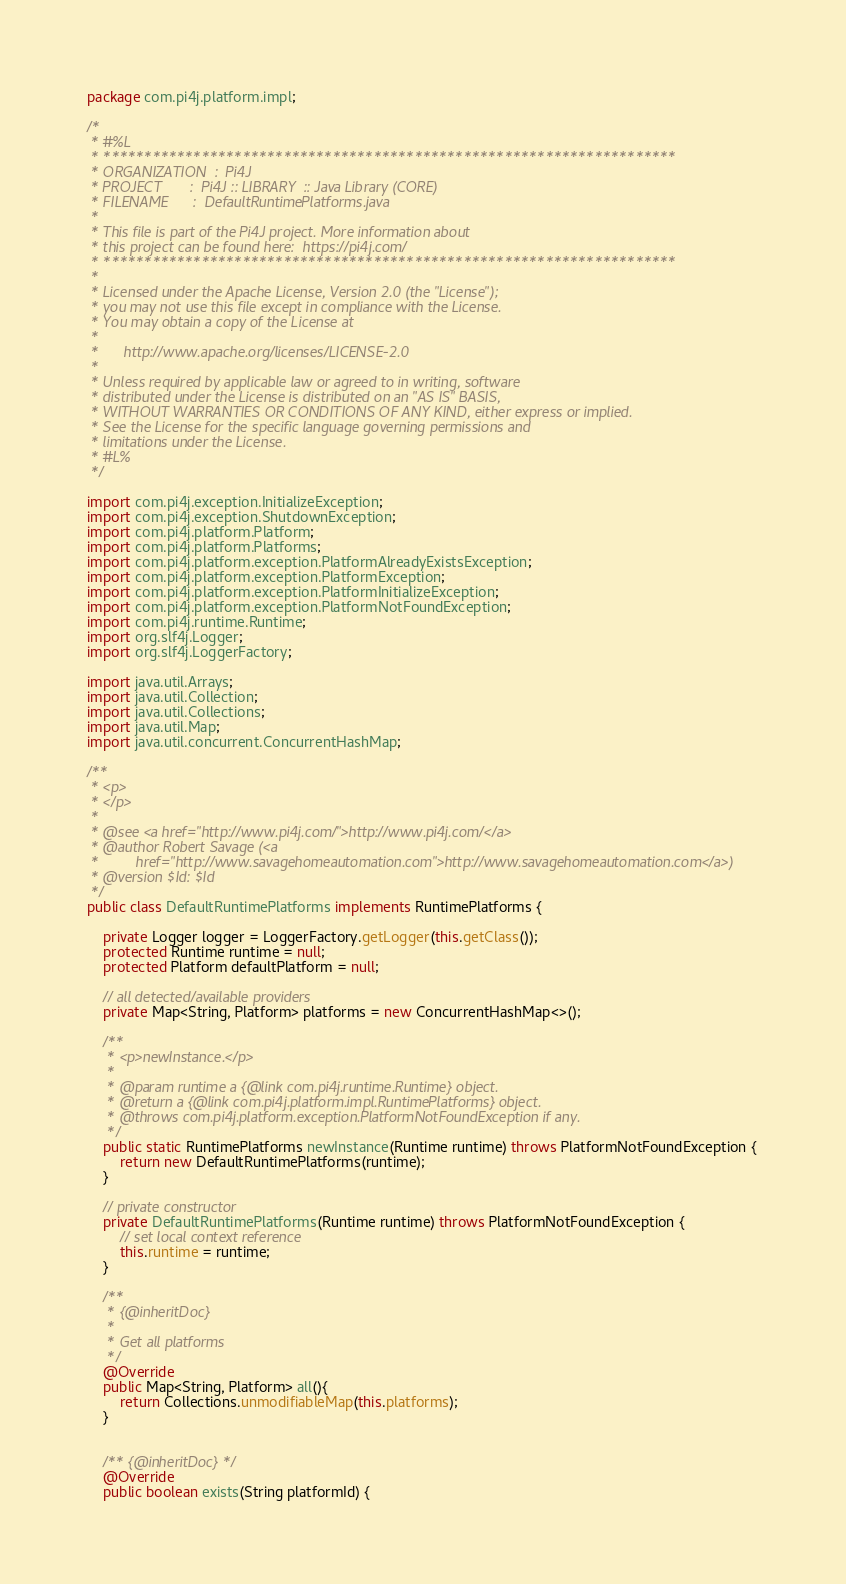<code> <loc_0><loc_0><loc_500><loc_500><_Java_>package com.pi4j.platform.impl;

/*
 * #%L
 * **********************************************************************
 * ORGANIZATION  :  Pi4J
 * PROJECT       :  Pi4J :: LIBRARY  :: Java Library (CORE)
 * FILENAME      :  DefaultRuntimePlatforms.java
 *
 * This file is part of the Pi4J project. More information about
 * this project can be found here:  https://pi4j.com/
 * **********************************************************************
 *
 * Licensed under the Apache License, Version 2.0 (the "License");
 * you may not use this file except in compliance with the License.
 * You may obtain a copy of the License at
 *
 *      http://www.apache.org/licenses/LICENSE-2.0
 *
 * Unless required by applicable law or agreed to in writing, software
 * distributed under the License is distributed on an "AS IS" BASIS,
 * WITHOUT WARRANTIES OR CONDITIONS OF ANY KIND, either express or implied.
 * See the License for the specific language governing permissions and
 * limitations under the License.
 * #L%
 */

import com.pi4j.exception.InitializeException;
import com.pi4j.exception.ShutdownException;
import com.pi4j.platform.Platform;
import com.pi4j.platform.Platforms;
import com.pi4j.platform.exception.PlatformAlreadyExistsException;
import com.pi4j.platform.exception.PlatformException;
import com.pi4j.platform.exception.PlatformInitializeException;
import com.pi4j.platform.exception.PlatformNotFoundException;
import com.pi4j.runtime.Runtime;
import org.slf4j.Logger;
import org.slf4j.LoggerFactory;

import java.util.Arrays;
import java.util.Collection;
import java.util.Collections;
import java.util.Map;
import java.util.concurrent.ConcurrentHashMap;

/**
 * <p>
 * </p>
 *
 * @see <a href="http://www.pi4j.com/">http://www.pi4j.com/</a>
 * @author Robert Savage (<a
 *         href="http://www.savagehomeautomation.com">http://www.savagehomeautomation.com</a>)
 * @version $Id: $Id
 */
public class DefaultRuntimePlatforms implements RuntimePlatforms {

    private Logger logger = LoggerFactory.getLogger(this.getClass());
    protected Runtime runtime = null;
    protected Platform defaultPlatform = null;

    // all detected/available providers
    private Map<String, Platform> platforms = new ConcurrentHashMap<>();

    /**
     * <p>newInstance.</p>
     *
     * @param runtime a {@link com.pi4j.runtime.Runtime} object.
     * @return a {@link com.pi4j.platform.impl.RuntimePlatforms} object.
     * @throws com.pi4j.platform.exception.PlatformNotFoundException if any.
     */
    public static RuntimePlatforms newInstance(Runtime runtime) throws PlatformNotFoundException {
        return new DefaultRuntimePlatforms(runtime);
    }

    // private constructor
    private DefaultRuntimePlatforms(Runtime runtime) throws PlatformNotFoundException {
        // set local context reference
        this.runtime = runtime;
    }

    /**
     * {@inheritDoc}
     *
     * Get all platforms
     */
    @Override
    public Map<String, Platform> all(){
        return Collections.unmodifiableMap(this.platforms);
    }


    /** {@inheritDoc} */
    @Override
    public boolean exists(String platformId) {</code> 